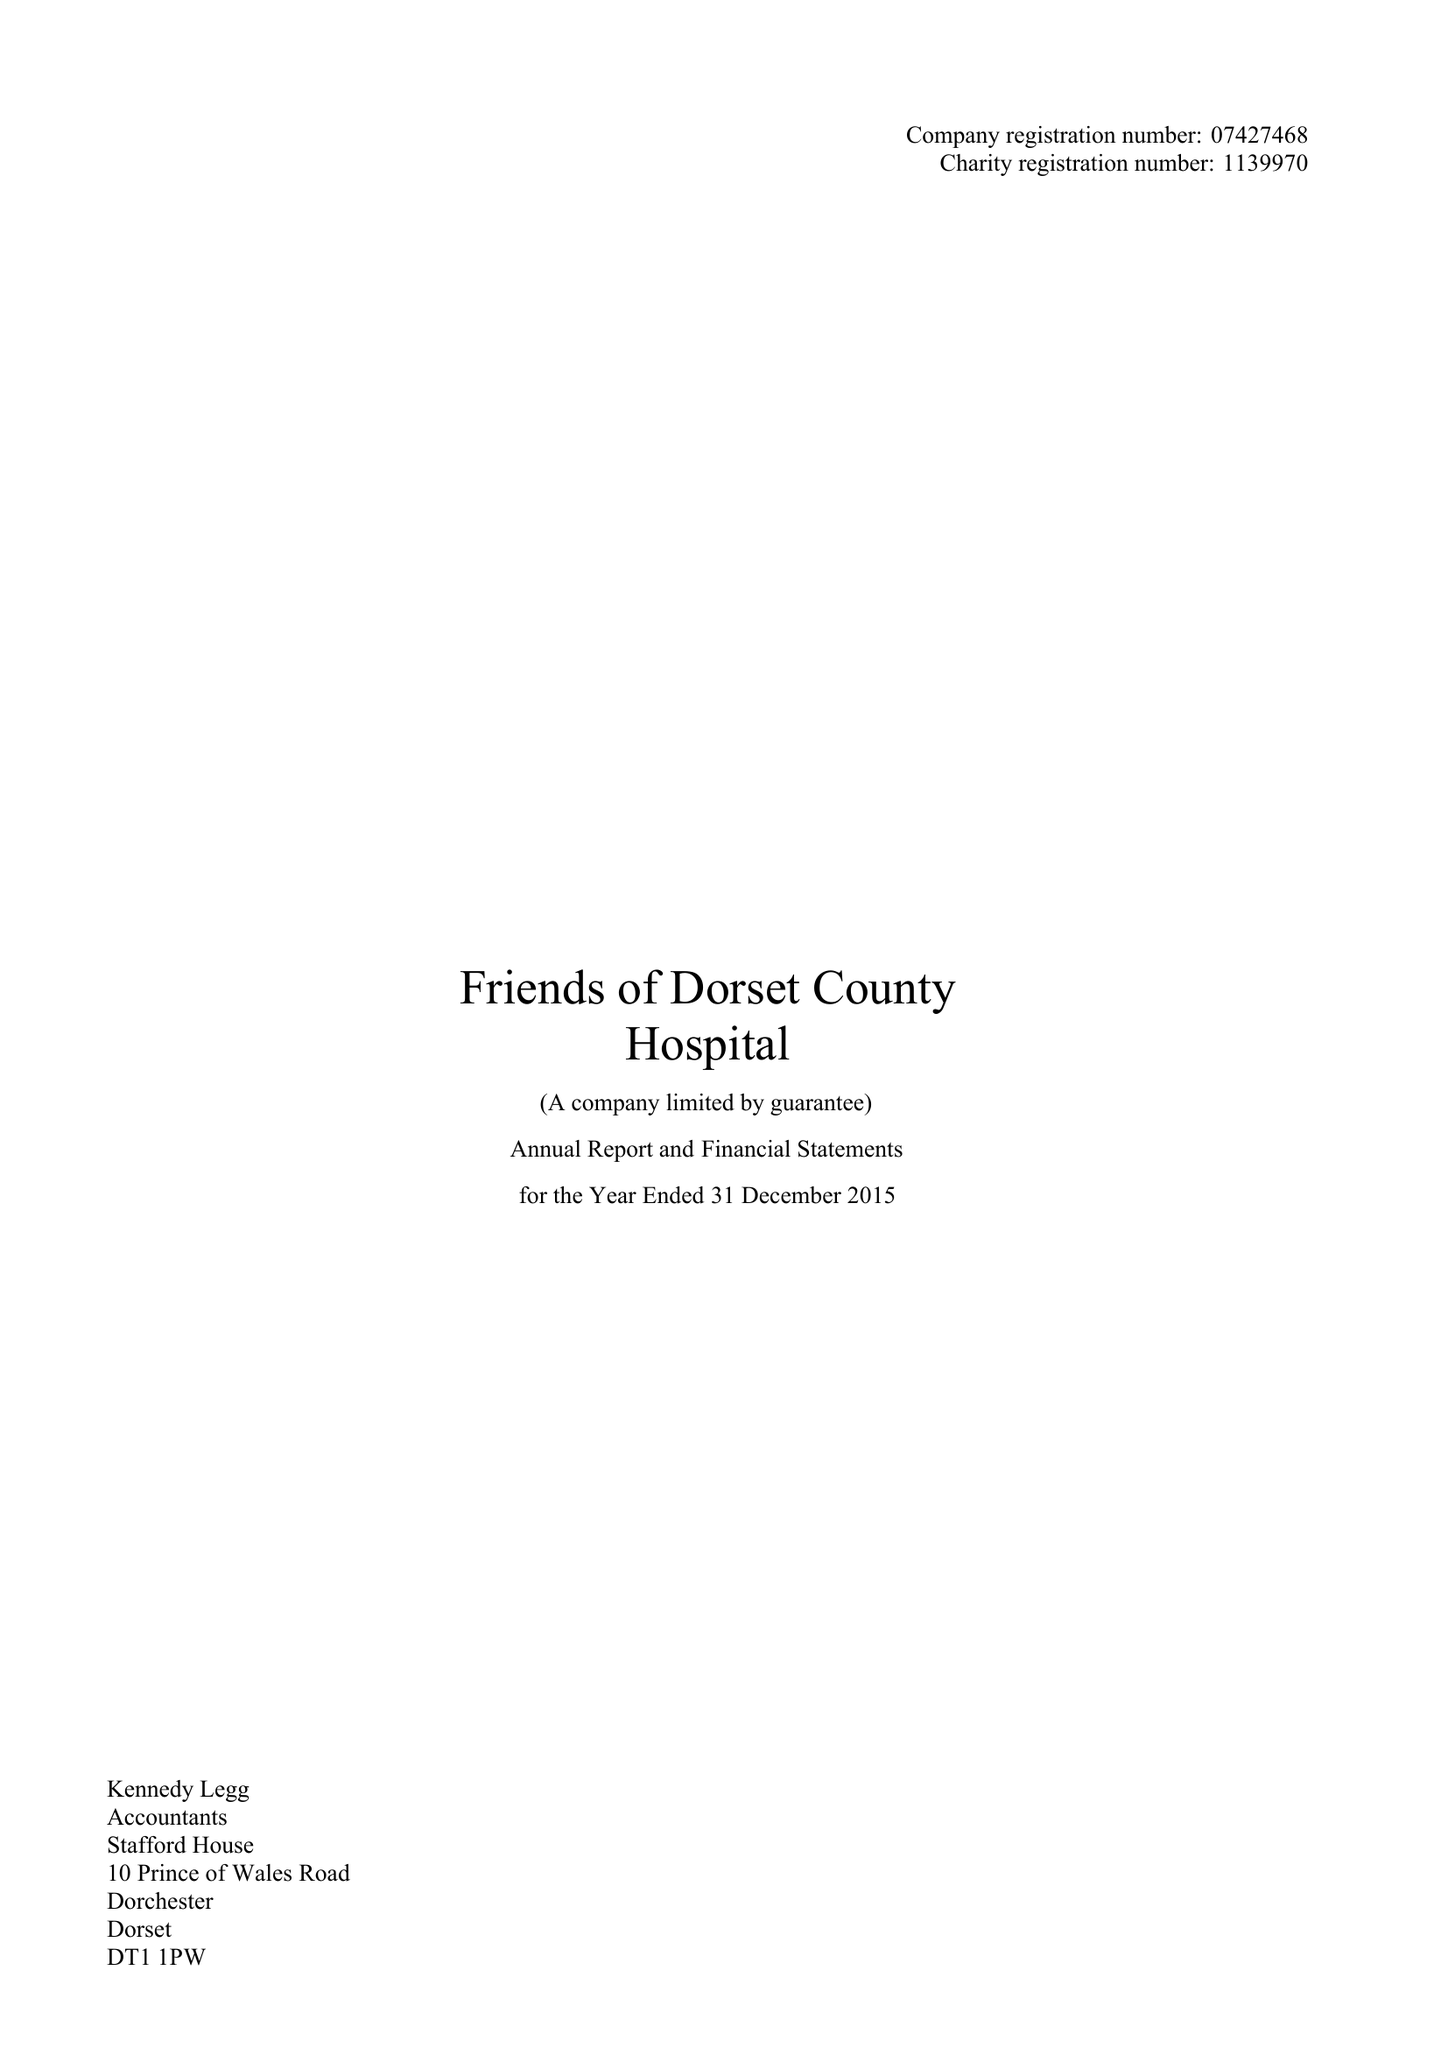What is the value for the charity_name?
Answer the question using a single word or phrase. Friends Of Dorset County Hospital 